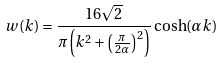Convert formula to latex. <formula><loc_0><loc_0><loc_500><loc_500>w ( k ) = \frac { 1 6 \sqrt { 2 } } { \pi \left ( k ^ { 2 } + \left ( \frac { \pi } { 2 \alpha } \right ) ^ { 2 } \right ) } \cosh ( \alpha k )</formula> 